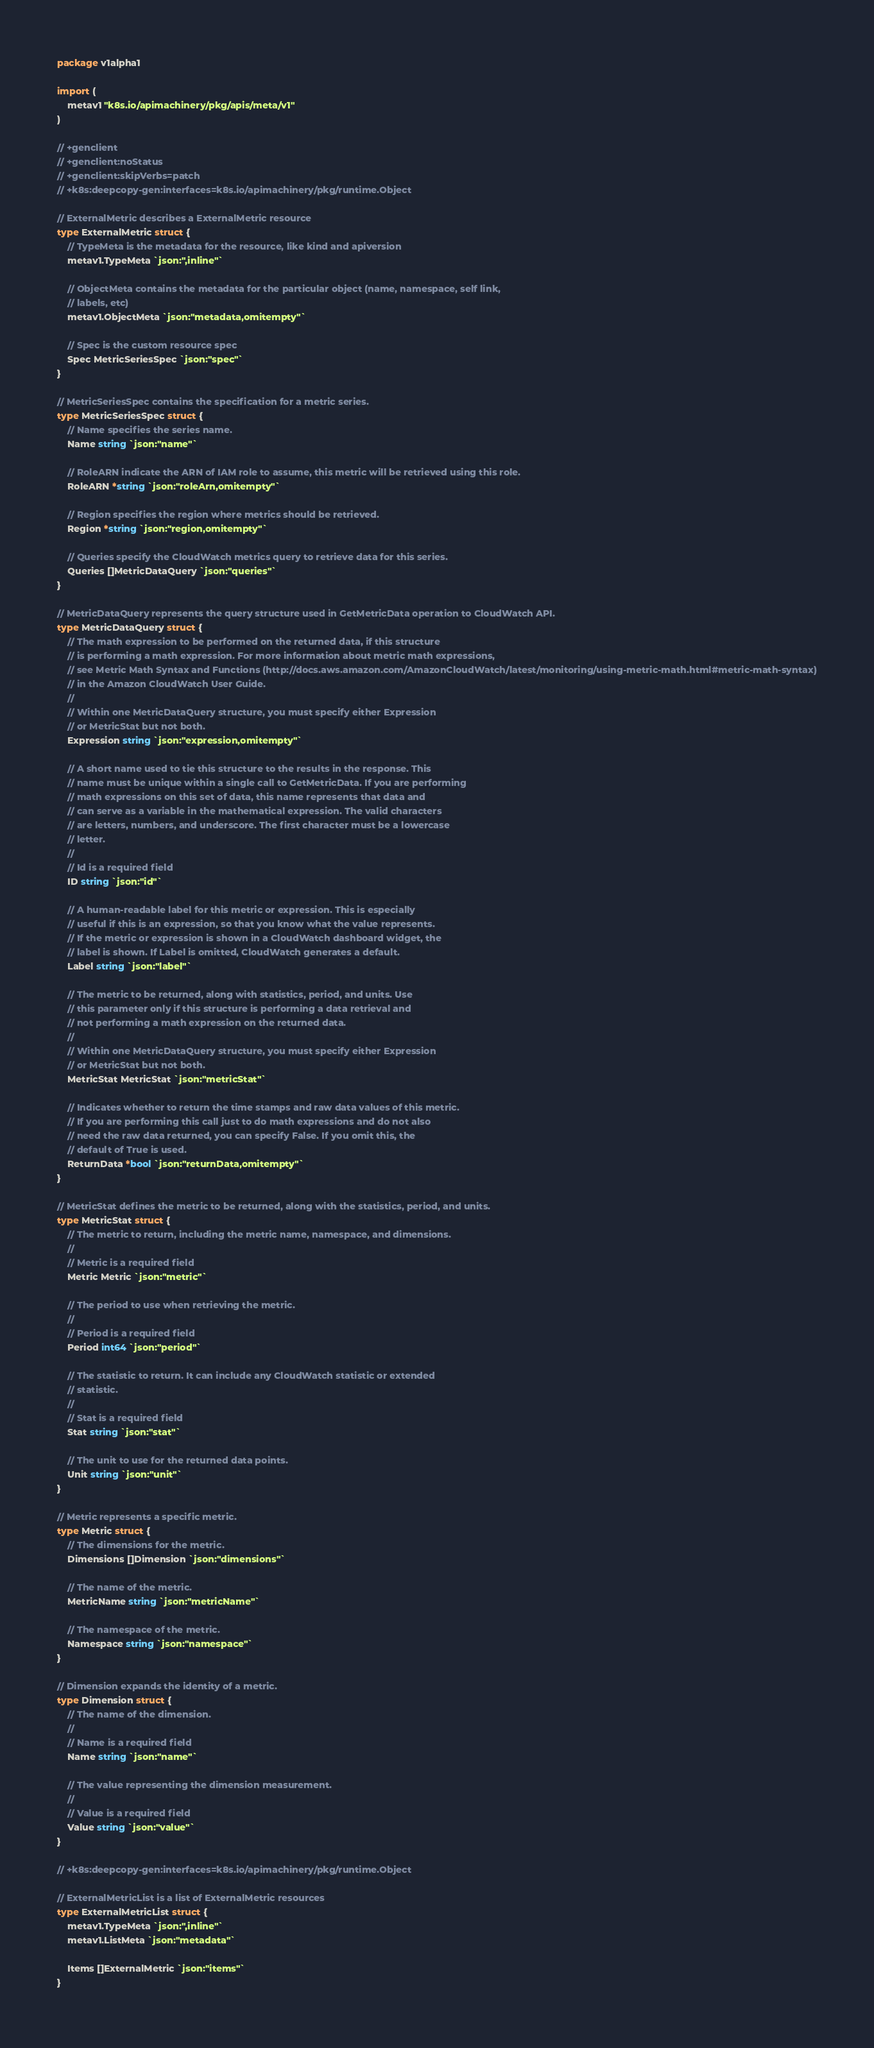<code> <loc_0><loc_0><loc_500><loc_500><_Go_>package v1alpha1

import (
	metav1 "k8s.io/apimachinery/pkg/apis/meta/v1"
)

// +genclient
// +genclient:noStatus
// +genclient:skipVerbs=patch
// +k8s:deepcopy-gen:interfaces=k8s.io/apimachinery/pkg/runtime.Object

// ExternalMetric describes a ExternalMetric resource
type ExternalMetric struct {
	// TypeMeta is the metadata for the resource, like kind and apiversion
	metav1.TypeMeta `json:",inline"`

	// ObjectMeta contains the metadata for the particular object (name, namespace, self link,
	// labels, etc)
	metav1.ObjectMeta `json:"metadata,omitempty"`

	// Spec is the custom resource spec
	Spec MetricSeriesSpec `json:"spec"`
}

// MetricSeriesSpec contains the specification for a metric series.
type MetricSeriesSpec struct {
	// Name specifies the series name.
	Name string `json:"name"`

	// RoleARN indicate the ARN of IAM role to assume, this metric will be retrieved using this role.
	RoleARN *string `json:"roleArn,omitempty"`

	// Region specifies the region where metrics should be retrieved.
	Region *string `json:"region,omitempty"`

	// Queries specify the CloudWatch metrics query to retrieve data for this series.
	Queries []MetricDataQuery `json:"queries"`
}

// MetricDataQuery represents the query structure used in GetMetricData operation to CloudWatch API.
type MetricDataQuery struct {
	// The math expression to be performed on the returned data, if this structure
	// is performing a math expression. For more information about metric math expressions,
	// see Metric Math Syntax and Functions (http://docs.aws.amazon.com/AmazonCloudWatch/latest/monitoring/using-metric-math.html#metric-math-syntax)
	// in the Amazon CloudWatch User Guide.
	//
	// Within one MetricDataQuery structure, you must specify either Expression
	// or MetricStat but not both.
	Expression string `json:"expression,omitempty"`

	// A short name used to tie this structure to the results in the response. This
	// name must be unique within a single call to GetMetricData. If you are performing
	// math expressions on this set of data, this name represents that data and
	// can serve as a variable in the mathematical expression. The valid characters
	// are letters, numbers, and underscore. The first character must be a lowercase
	// letter.
	//
	// Id is a required field
	ID string `json:"id"`

	// A human-readable label for this metric or expression. This is especially
	// useful if this is an expression, so that you know what the value represents.
	// If the metric or expression is shown in a CloudWatch dashboard widget, the
	// label is shown. If Label is omitted, CloudWatch generates a default.
	Label string `json:"label"`

	// The metric to be returned, along with statistics, period, and units. Use
	// this parameter only if this structure is performing a data retrieval and
	// not performing a math expression on the returned data.
	//
	// Within one MetricDataQuery structure, you must specify either Expression
	// or MetricStat but not both.
	MetricStat MetricStat `json:"metricStat"`

	// Indicates whether to return the time stamps and raw data values of this metric.
	// If you are performing this call just to do math expressions and do not also
	// need the raw data returned, you can specify False. If you omit this, the
	// default of True is used.
	ReturnData *bool `json:"returnData,omitempty"`
}

// MetricStat defines the metric to be returned, along with the statistics, period, and units.
type MetricStat struct {
	// The metric to return, including the metric name, namespace, and dimensions.
	//
	// Metric is a required field
	Metric Metric `json:"metric"`

	// The period to use when retrieving the metric.
	//
	// Period is a required field
	Period int64 `json:"period"`

	// The statistic to return. It can include any CloudWatch statistic or extended
	// statistic.
	//
	// Stat is a required field
	Stat string `json:"stat"`

	// The unit to use for the returned data points.
	Unit string `json:"unit"`
}

// Metric represents a specific metric.
type Metric struct {
	// The dimensions for the metric.
	Dimensions []Dimension `json:"dimensions"`

	// The name of the metric.
	MetricName string `json:"metricName"`

	// The namespace of the metric.
	Namespace string `json:"namespace"`
}

// Dimension expands the identity of a metric.
type Dimension struct {
	// The name of the dimension.
	//
	// Name is a required field
	Name string `json:"name"`

	// The value representing the dimension measurement.
	//
	// Value is a required field
	Value string `json:"value"`
}

// +k8s:deepcopy-gen:interfaces=k8s.io/apimachinery/pkg/runtime.Object

// ExternalMetricList is a list of ExternalMetric resources
type ExternalMetricList struct {
	metav1.TypeMeta `json:",inline"`
	metav1.ListMeta `json:"metadata"`

	Items []ExternalMetric `json:"items"`
}
</code> 